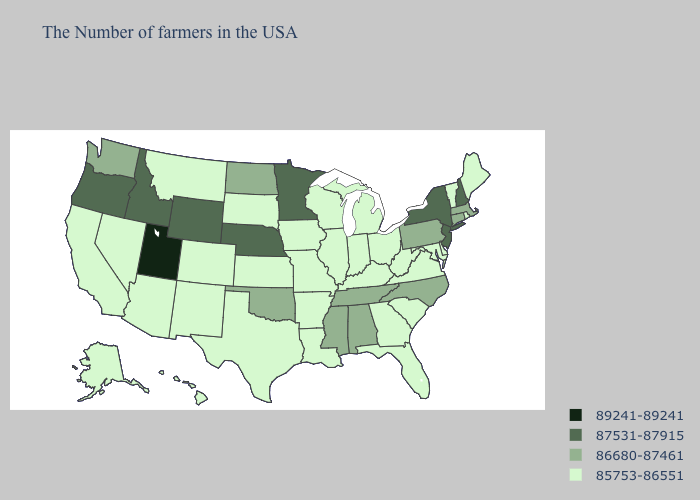Among the states that border South Dakota , which have the lowest value?
Answer briefly. Iowa, Montana. Name the states that have a value in the range 89241-89241?
Short answer required. Utah. What is the value of Arkansas?
Quick response, please. 85753-86551. What is the lowest value in the South?
Be succinct. 85753-86551. Among the states that border Michigan , which have the highest value?
Quick response, please. Ohio, Indiana, Wisconsin. Name the states that have a value in the range 87531-87915?
Be succinct. New Hampshire, New York, New Jersey, Minnesota, Nebraska, Wyoming, Idaho, Oregon. Does Mississippi have the highest value in the South?
Concise answer only. Yes. What is the value of Kentucky?
Keep it brief. 85753-86551. Does Washington have a higher value than New Jersey?
Keep it brief. No. What is the lowest value in the USA?
Be succinct. 85753-86551. Name the states that have a value in the range 89241-89241?
Keep it brief. Utah. What is the value of Arizona?
Keep it brief. 85753-86551. Does New Mexico have the same value as South Dakota?
Concise answer only. Yes. What is the value of Oklahoma?
Answer briefly. 86680-87461. Which states have the highest value in the USA?
Give a very brief answer. Utah. 